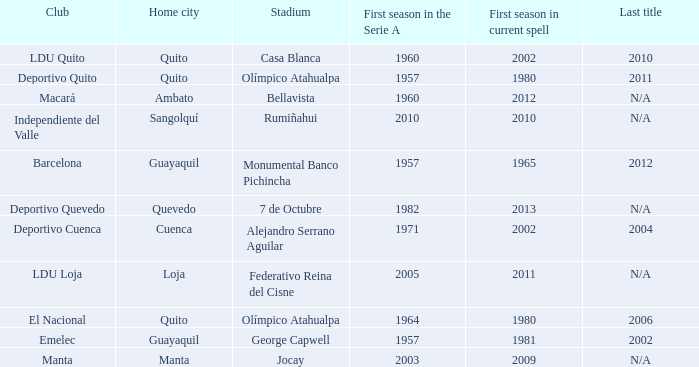Name the last title for 2012 N/A. 